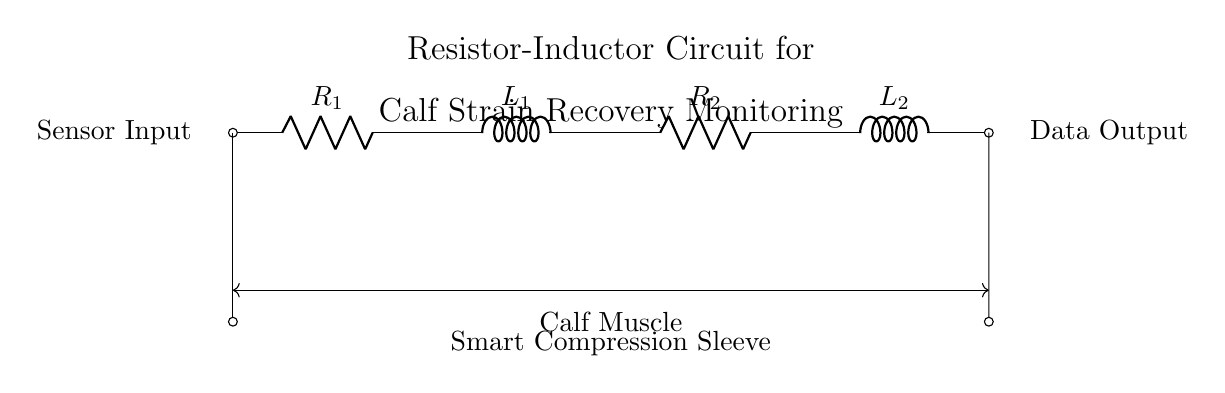What types of components are used in this circuit? The circuit diagram shows two resistors and two inductors. Resistors are denoted as R and inductors as L in the diagram.
Answer: Resistor and Inductor What is the purpose of the circuit? The circuit is designed for monitoring calf strain recovery progress through a smart compression sleeve. This is indicated by the label in the diagram.
Answer: Monitor calf strain How many resistors are present in the circuit? The diagram clearly shows two components labeled as resistors (R1 and R2) in the circuit, which indicates the number of resistors.
Answer: Two What do the arrows attached to the components signify? The arrows indicate the input and output connections in the circuit. The short lines at both ends suggest points where sensors and data output are connected.
Answer: Input and output What type of circuit is represented in this diagram? This is a Resistor-Inductor circuit, as it includes both resistors and inductors in its layout. The combination of these elements defines the circuit type.
Answer: Resistor-Inductor circuit How does the resistor-inductor combination affect the monitoring of muscle strain? The R-L circuit's response to voltage change can help analyze the muscle's electrical characteristics, relevant for understanding strain recovery. The components together form a circuit that can respond to and measure changes related to muscle condition.
Answer: Analyzes muscle recovery 